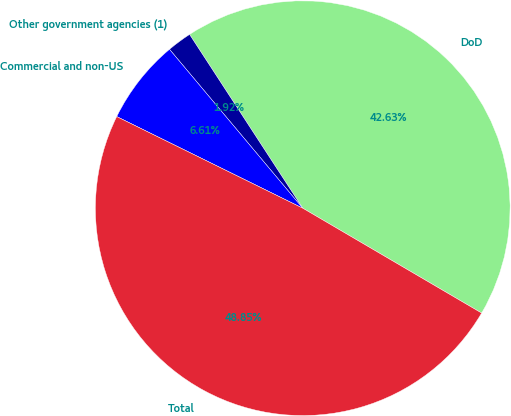<chart> <loc_0><loc_0><loc_500><loc_500><pie_chart><fcel>DoD<fcel>Other government agencies (1)<fcel>Commercial and non-US<fcel>Total<nl><fcel>42.63%<fcel>1.92%<fcel>6.61%<fcel>48.85%<nl></chart> 